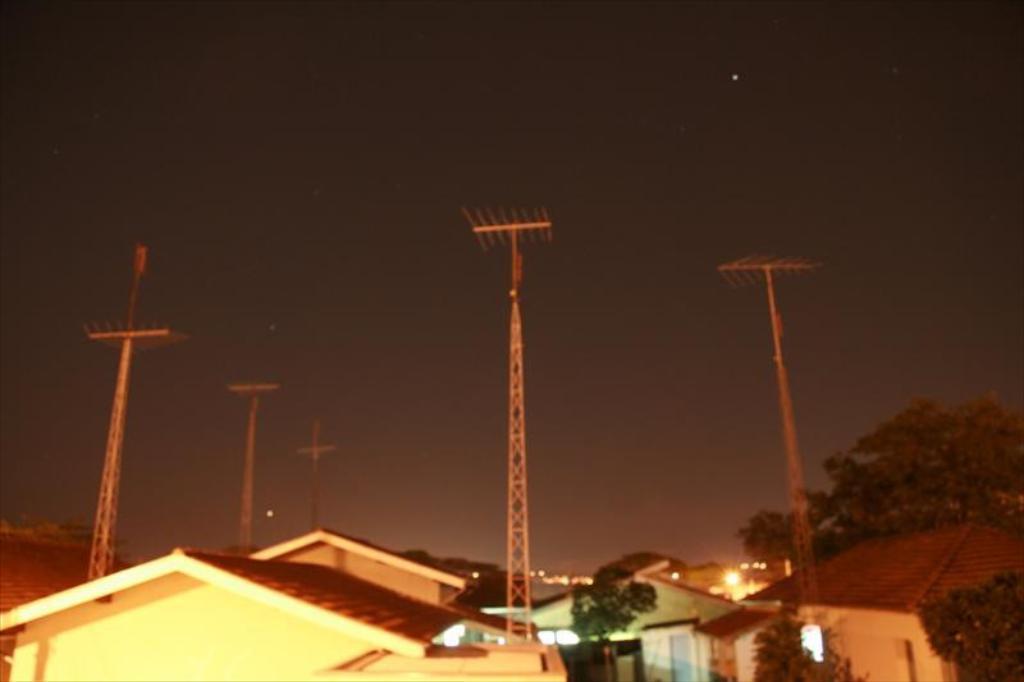Can you describe this image briefly? In the image we can see there are many buildings and trees, these are the antennas, light and a sky. We can even see the stars in the sky. 